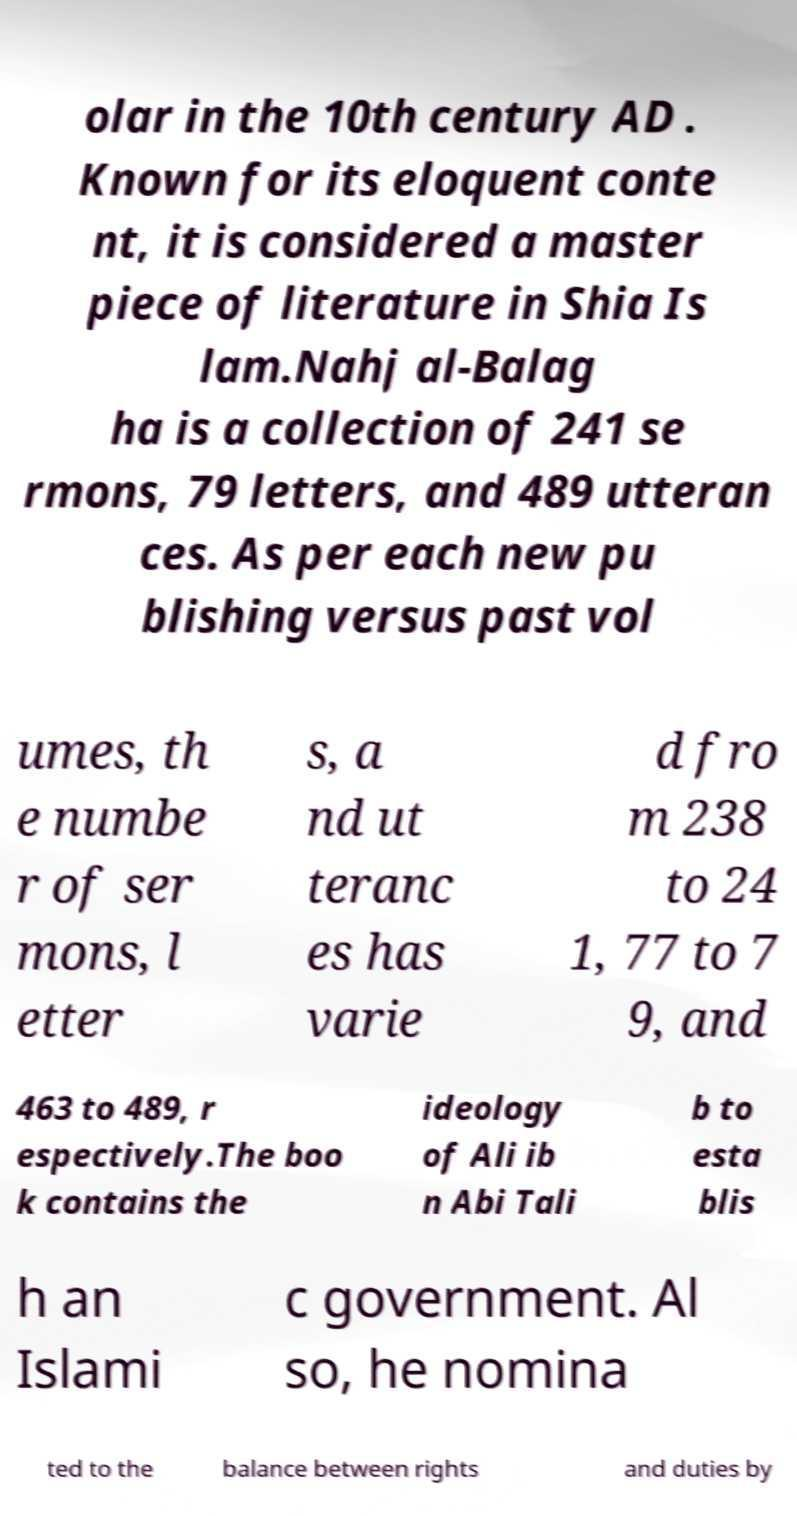Could you assist in decoding the text presented in this image and type it out clearly? olar in the 10th century AD . Known for its eloquent conte nt, it is considered a master piece of literature in Shia Is lam.Nahj al-Balag ha is a collection of 241 se rmons, 79 letters, and 489 utteran ces. As per each new pu blishing versus past vol umes, th e numbe r of ser mons, l etter s, a nd ut teranc es has varie d fro m 238 to 24 1, 77 to 7 9, and 463 to 489, r espectively.The boo k contains the ideology of Ali ib n Abi Tali b to esta blis h an Islami c government. Al so, he nomina ted to the balance between rights and duties by 